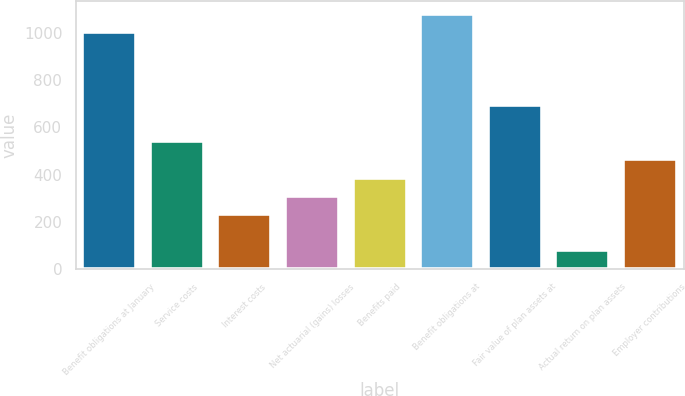Convert chart. <chart><loc_0><loc_0><loc_500><loc_500><bar_chart><fcel>Benefit obligations at January<fcel>Service costs<fcel>Interest costs<fcel>Net actuarial (gains) losses<fcel>Benefits paid<fcel>Benefit obligations at<fcel>Fair value of plan assets at<fcel>Actual return on plan assets<fcel>Employer contributions<nl><fcel>1004.3<fcel>541.7<fcel>233.3<fcel>310.4<fcel>387.5<fcel>1081.4<fcel>695.9<fcel>79.1<fcel>464.6<nl></chart> 